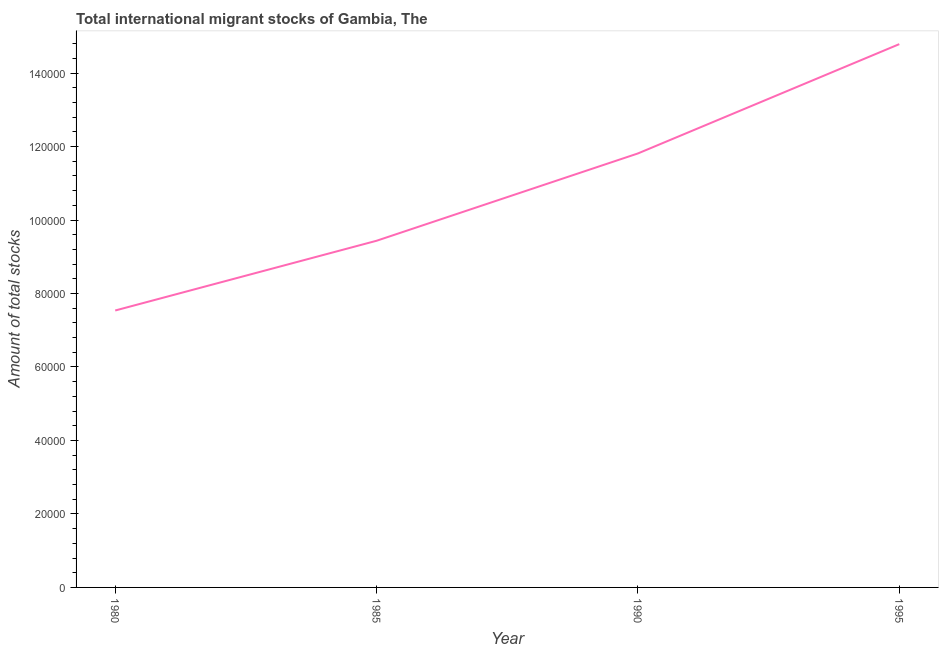What is the total number of international migrant stock in 1985?
Your response must be concise. 9.44e+04. Across all years, what is the maximum total number of international migrant stock?
Provide a short and direct response. 1.48e+05. Across all years, what is the minimum total number of international migrant stock?
Make the answer very short. 7.54e+04. In which year was the total number of international migrant stock minimum?
Make the answer very short. 1980. What is the sum of the total number of international migrant stock?
Keep it short and to the point. 4.36e+05. What is the difference between the total number of international migrant stock in 1980 and 1990?
Your answer should be compact. -4.27e+04. What is the average total number of international migrant stock per year?
Make the answer very short. 1.09e+05. What is the median total number of international migrant stock?
Your answer should be very brief. 1.06e+05. What is the ratio of the total number of international migrant stock in 1980 to that in 1985?
Your answer should be compact. 0.8. What is the difference between the highest and the second highest total number of international migrant stock?
Provide a short and direct response. 2.98e+04. What is the difference between the highest and the lowest total number of international migrant stock?
Your answer should be very brief. 7.25e+04. In how many years, is the total number of international migrant stock greater than the average total number of international migrant stock taken over all years?
Ensure brevity in your answer.  2. How many lines are there?
Your answer should be very brief. 1. How many years are there in the graph?
Offer a very short reply. 4. Does the graph contain any zero values?
Your answer should be compact. No. Does the graph contain grids?
Your answer should be very brief. No. What is the title of the graph?
Provide a succinct answer. Total international migrant stocks of Gambia, The. What is the label or title of the Y-axis?
Make the answer very short. Amount of total stocks. What is the Amount of total stocks in 1980?
Your answer should be very brief. 7.54e+04. What is the Amount of total stocks in 1985?
Your answer should be very brief. 9.44e+04. What is the Amount of total stocks of 1990?
Your answer should be very brief. 1.18e+05. What is the Amount of total stocks in 1995?
Give a very brief answer. 1.48e+05. What is the difference between the Amount of total stocks in 1980 and 1985?
Your answer should be very brief. -1.90e+04. What is the difference between the Amount of total stocks in 1980 and 1990?
Make the answer very short. -4.27e+04. What is the difference between the Amount of total stocks in 1980 and 1995?
Make the answer very short. -7.25e+04. What is the difference between the Amount of total stocks in 1985 and 1990?
Ensure brevity in your answer.  -2.38e+04. What is the difference between the Amount of total stocks in 1985 and 1995?
Give a very brief answer. -5.35e+04. What is the difference between the Amount of total stocks in 1990 and 1995?
Offer a terse response. -2.98e+04. What is the ratio of the Amount of total stocks in 1980 to that in 1985?
Your answer should be very brief. 0.8. What is the ratio of the Amount of total stocks in 1980 to that in 1990?
Offer a terse response. 0.64. What is the ratio of the Amount of total stocks in 1980 to that in 1995?
Give a very brief answer. 0.51. What is the ratio of the Amount of total stocks in 1985 to that in 1990?
Make the answer very short. 0.8. What is the ratio of the Amount of total stocks in 1985 to that in 1995?
Ensure brevity in your answer.  0.64. What is the ratio of the Amount of total stocks in 1990 to that in 1995?
Ensure brevity in your answer.  0.8. 